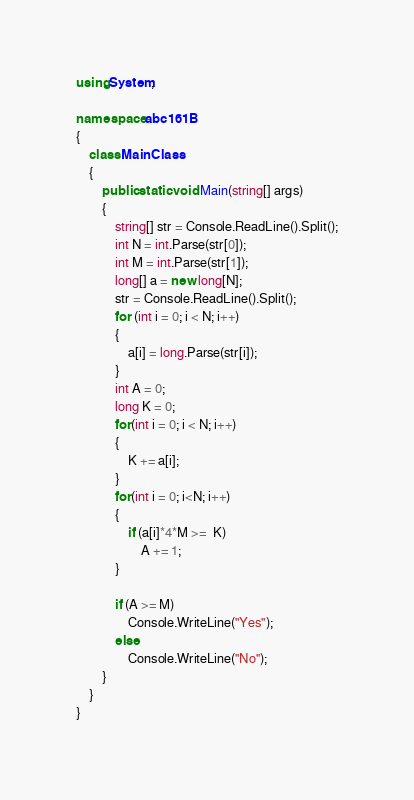Convert code to text. <code><loc_0><loc_0><loc_500><loc_500><_C#_>using System;

namespace abc161B
{
    class MainClass
    {
        public static void Main(string[] args)
        {
            string[] str = Console.ReadLine().Split();
            int N = int.Parse(str[0]);
            int M = int.Parse(str[1]);
            long[] a = new long[N];
            str = Console.ReadLine().Split();
            for (int i = 0; i < N; i++)
            {
                a[i] = long.Parse(str[i]);
            }
            int A = 0;
            long K = 0;
            for(int i = 0; i < N; i++)
            {
                K += a[i];
            }
            for(int i = 0; i<N; i++)
            {
                if (a[i]*4*M >=  K) 
                    A += 1; 
            }
            
            if (A >= M)
                Console.WriteLine("Yes");
            else
                Console.WriteLine("No");
        }
    }
}
</code> 